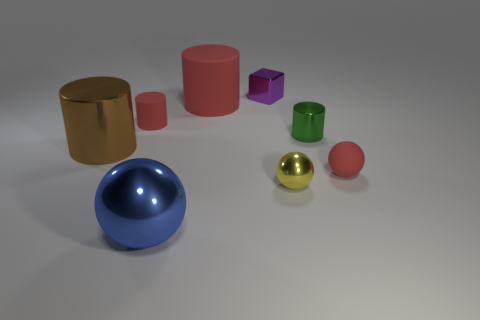Are there fewer blue metallic cylinders than red rubber things?
Give a very brief answer. Yes. What number of tiny spheres are the same material as the small purple block?
Ensure brevity in your answer.  1. What is the color of the small sphere that is made of the same material as the purple thing?
Ensure brevity in your answer.  Yellow. The green object is what shape?
Your answer should be compact. Cylinder. What number of large metallic balls have the same color as the small metal cube?
Keep it short and to the point. 0. What shape is the green metal object that is the same size as the yellow metallic object?
Offer a terse response. Cylinder. Is there a purple block of the same size as the red ball?
Offer a terse response. Yes. There is a red ball that is the same size as the yellow metal thing; what is it made of?
Make the answer very short. Rubber. There is a red matte thing that is in front of the small rubber thing that is left of the green shiny cylinder; what size is it?
Keep it short and to the point. Small. Is the size of the brown metallic cylinder on the left side of the red ball the same as the large blue sphere?
Provide a short and direct response. Yes. 